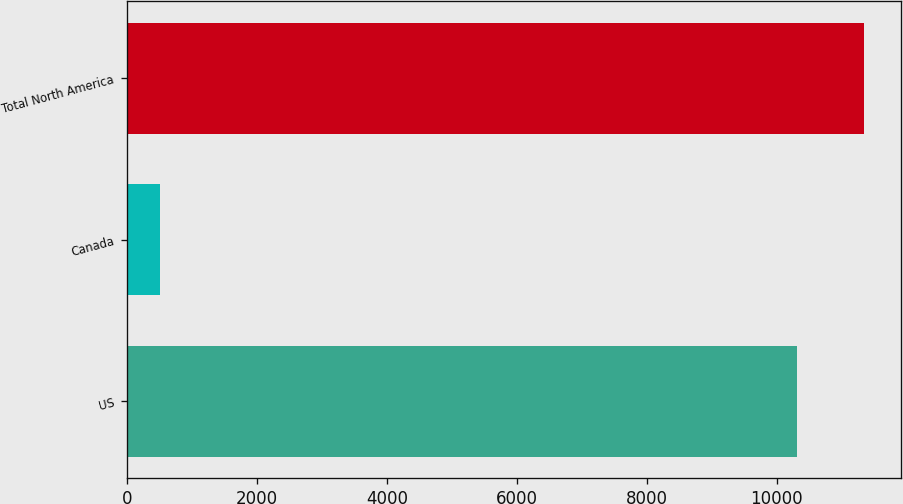Convert chart. <chart><loc_0><loc_0><loc_500><loc_500><bar_chart><fcel>US<fcel>Canada<fcel>Total North America<nl><fcel>10313<fcel>498<fcel>11344.3<nl></chart> 